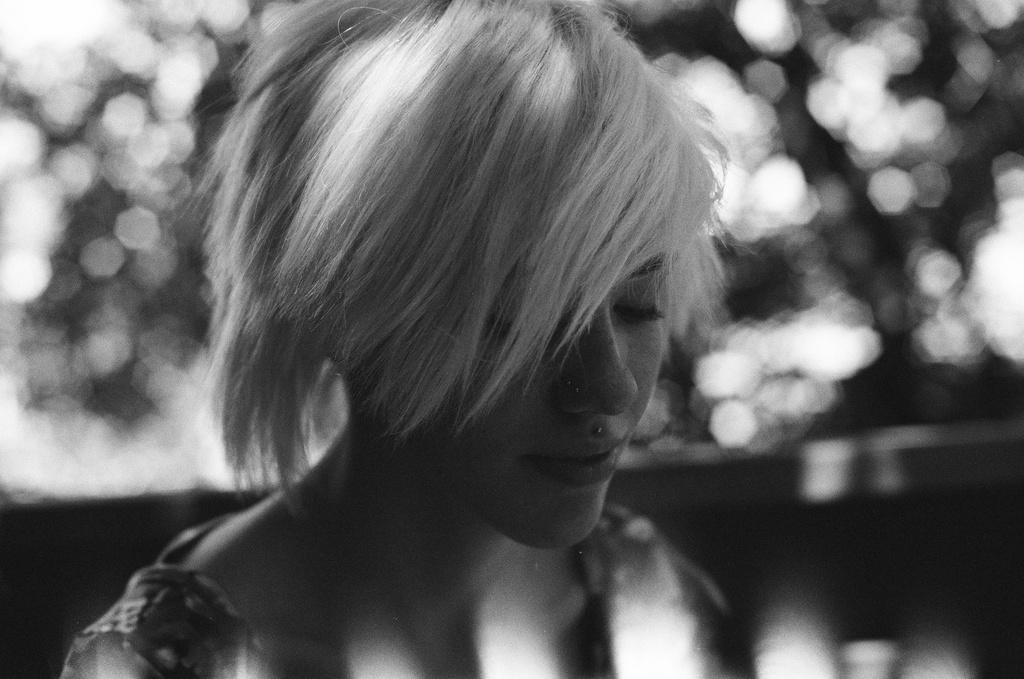How would you summarize this image in a sentence or two? In this picture we can see a woman smiling and in the background it is blurry. 